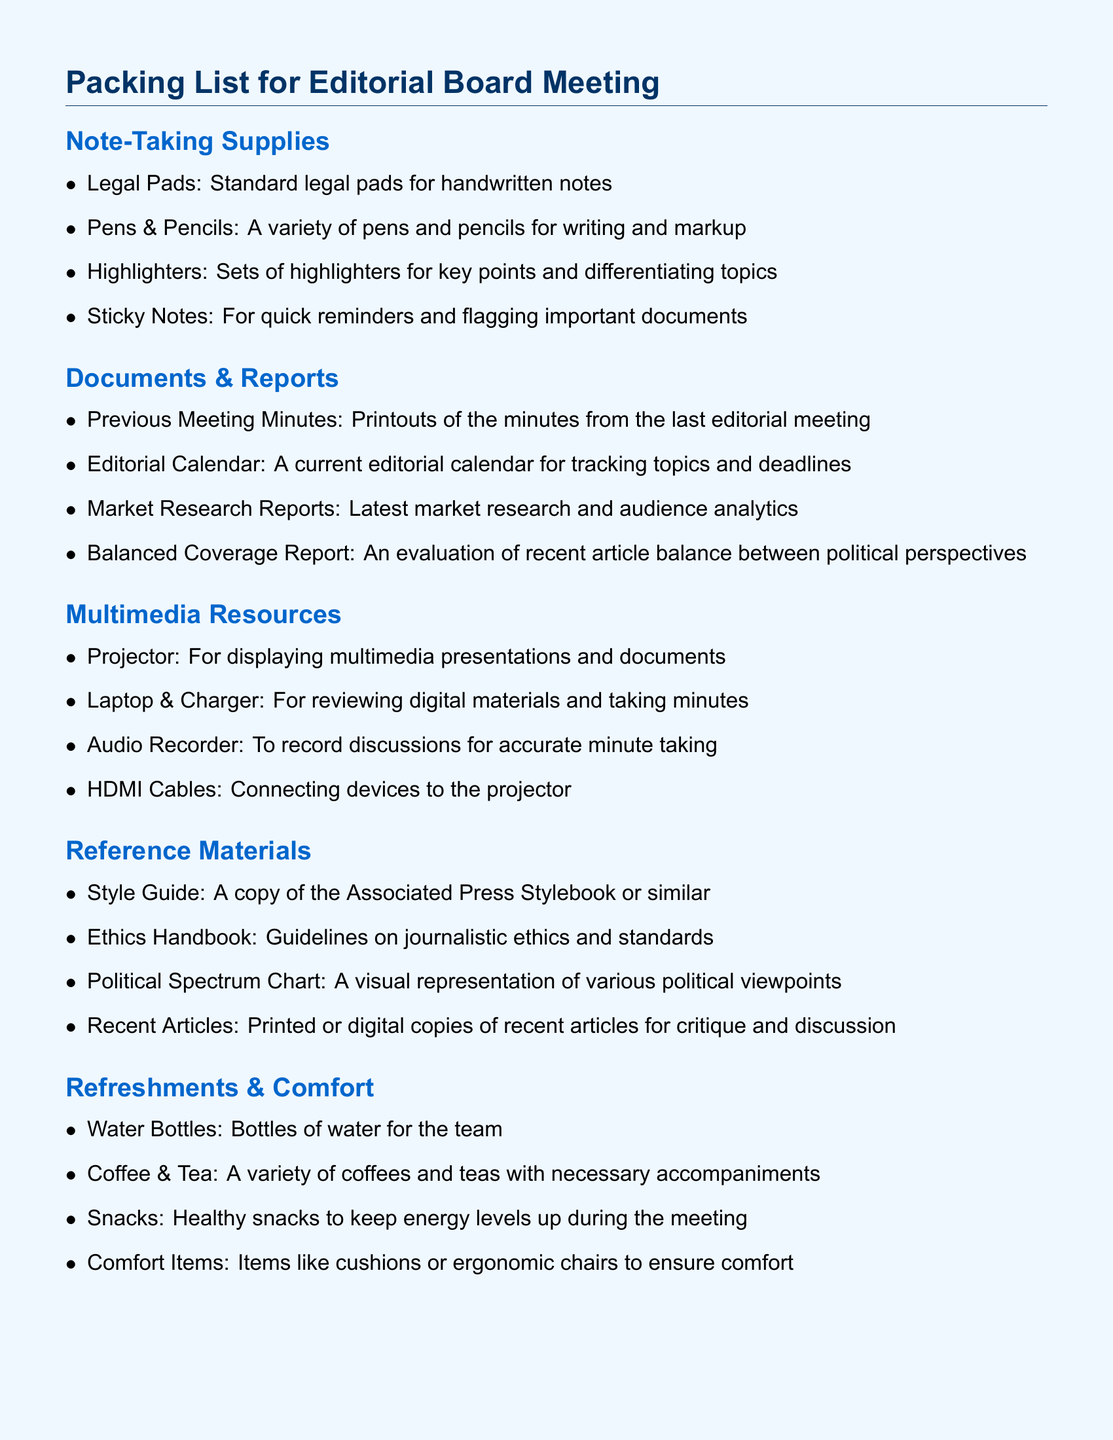What items are listed under Note-Taking Supplies? The items under Note-Taking Supplies include legal pads, pens, pencils, highlighters, and sticky notes.
Answer: legal pads, pens & pencils, highlighters, sticky notes How many types of refreshments are included? The document lists four types of refreshments including water bottles, coffee, tea, and snacks.
Answer: 4 What document includes the minutes from the previous meeting? The document that contains the minutes from the previous meeting is titled "Previous Meeting Minutes."
Answer: Previous Meeting Minutes What multimedia resource is specified for displaying presentations? The specified multimedia resource for displaying presentations is a projector.
Answer: projector What is the purpose of the Balanced Coverage Report? The Balanced Coverage Report evaluates the recent article balance between political perspectives.
Answer: Evaluation of recent article balance Which reference material provides guidelines on journalistic ethics? The reference material that provides guidelines on journalistic ethics is the Ethics Handbook.
Answer: Ethics Handbook What comfort item is suggested for ensuring comfort during the meeting? The suggested comfort item includes cushions or ergonomic chairs to ensure comfort.
Answer: cushions, ergonomic chairs How many items are mentioned under Refreshments & Comfort? There are four items mentioned under Refreshments & Comfort: water bottles, coffee & tea, snacks, and comfort items.
Answer: 4 Which document is used for tracking topics and deadlines? The document used for tracking topics and deadlines is the Editorial Calendar.
Answer: Editorial Calendar 